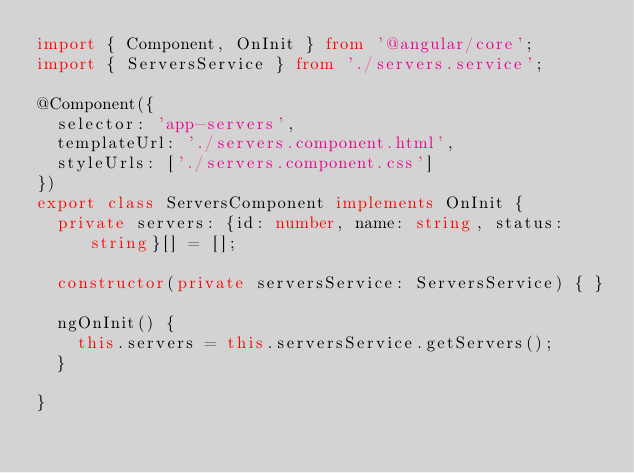Convert code to text. <code><loc_0><loc_0><loc_500><loc_500><_TypeScript_>import { Component, OnInit } from '@angular/core';
import { ServersService } from './servers.service';

@Component({
  selector: 'app-servers',
  templateUrl: './servers.component.html',
  styleUrls: ['./servers.component.css']
})
export class ServersComponent implements OnInit {
  private servers: {id: number, name: string, status: string}[] = [];

  constructor(private serversService: ServersService) { }

  ngOnInit() {
    this.servers = this.serversService.getServers();
  }

}
</code> 